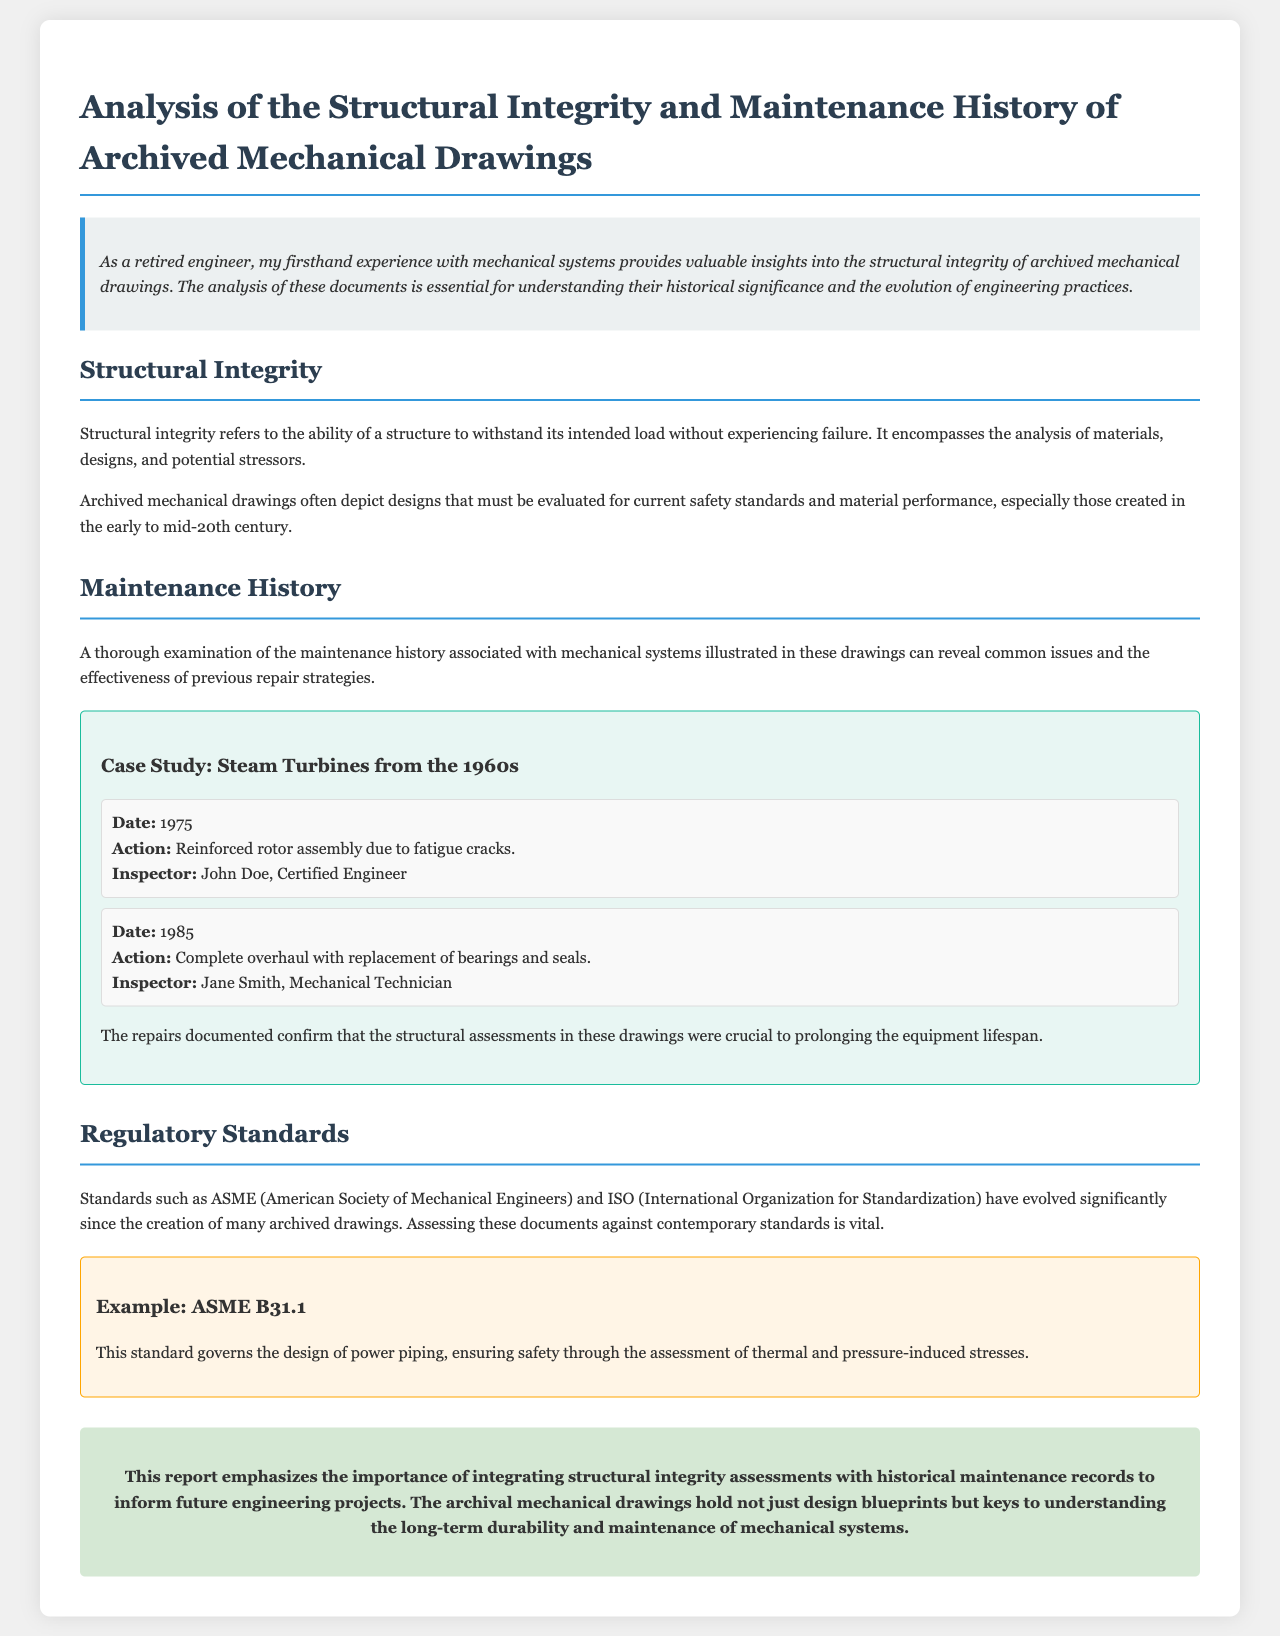What is the title of the report? The title of the report is specified in the header of the document, presenting the full scope of the analysis conducted.
Answer: Analysis of the Structural Integrity and Maintenance History of Archived Mechanical Drawings Who inspected the maintenance action in 1985? The document lists the names of inspectors alongside the respective maintenance actions for better traceability.
Answer: Jane Smith What was the date of the maintenance action involving reinforced rotor assembly? The document contains specific dates associated with maintenance actions, highlighting the timeline of these activities.
Answer: 1975 Which standard governs the design of power piping? The document mentions a specific standard relevant to the design and safety assessments within the discussed mechanical systems.
Answer: ASME B31.1 What type of integrity does the report emphasize? The report focuses on a specific aspect that's crucial to understanding the mechanical systems and their reliability.
Answer: Structural integrity What common issues does the maintenance history reveal? The document discusses the importance of examining maintenance history to uncover recurring problems in mechanical systems.
Answer: Common issues In which decade do the steam turbines in the case study originate? The document specifies the time frame for the subject of the case study, providing context for the historical analysis.
Answer: 1960s 